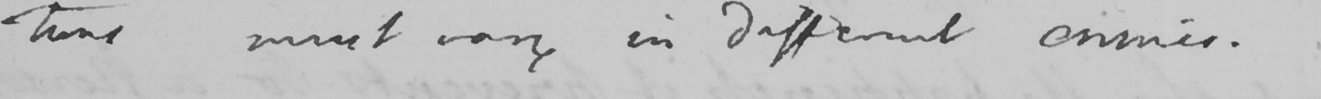What is written in this line of handwriting? -tions must vary in different crimes . 